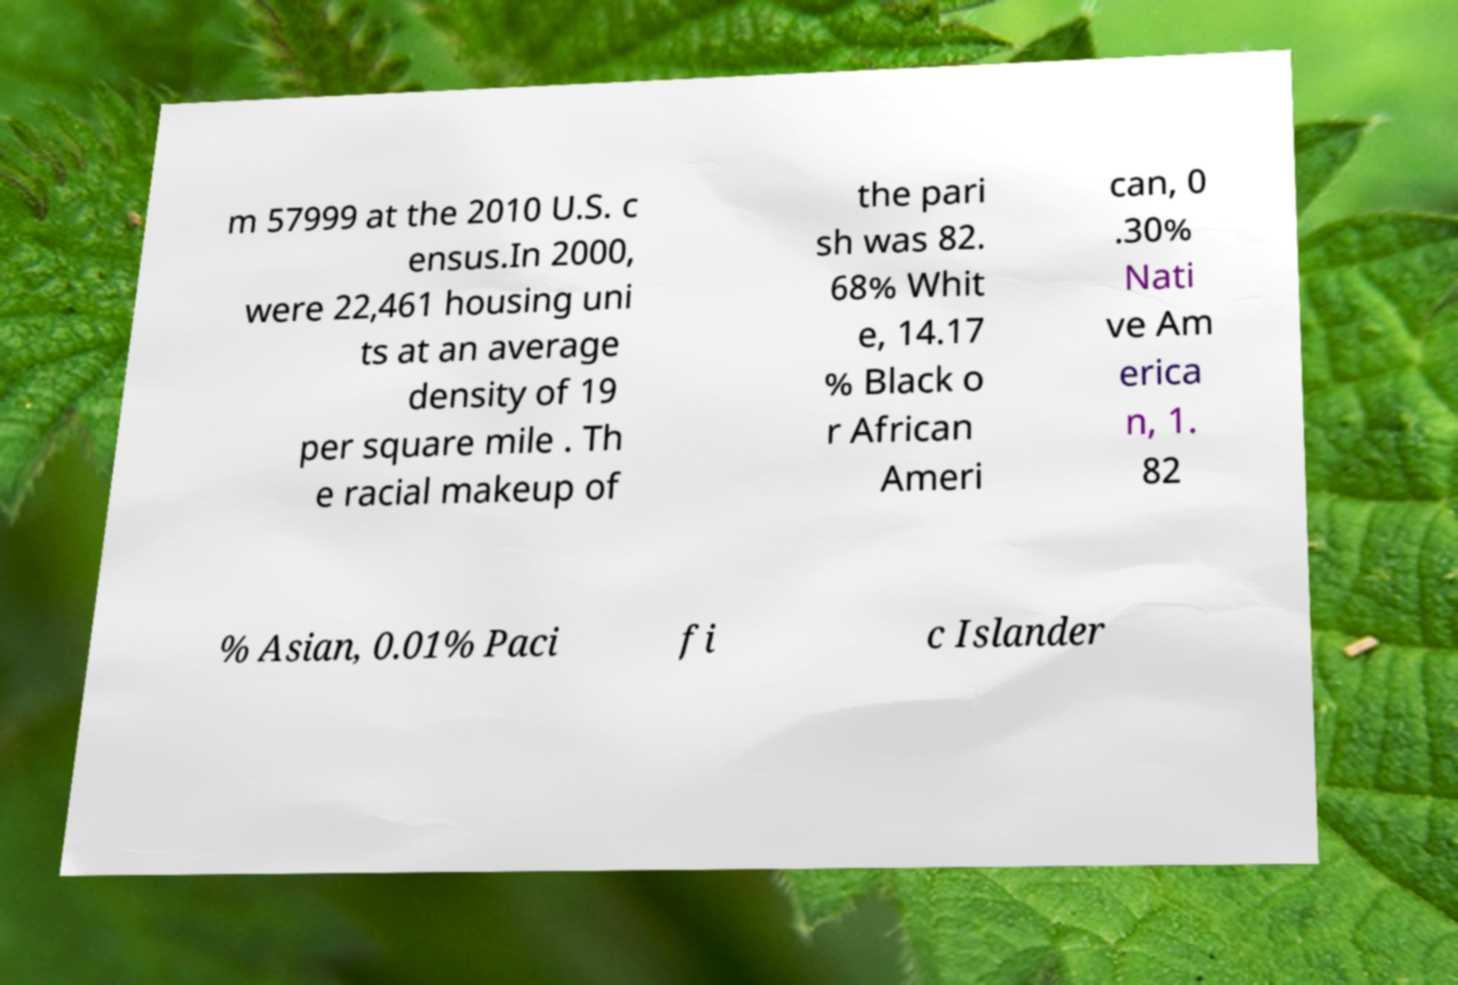Please identify and transcribe the text found in this image. m 57999 at the 2010 U.S. c ensus.In 2000, were 22,461 housing uni ts at an average density of 19 per square mile . Th e racial makeup of the pari sh was 82. 68% Whit e, 14.17 % Black o r African Ameri can, 0 .30% Nati ve Am erica n, 1. 82 % Asian, 0.01% Paci fi c Islander 